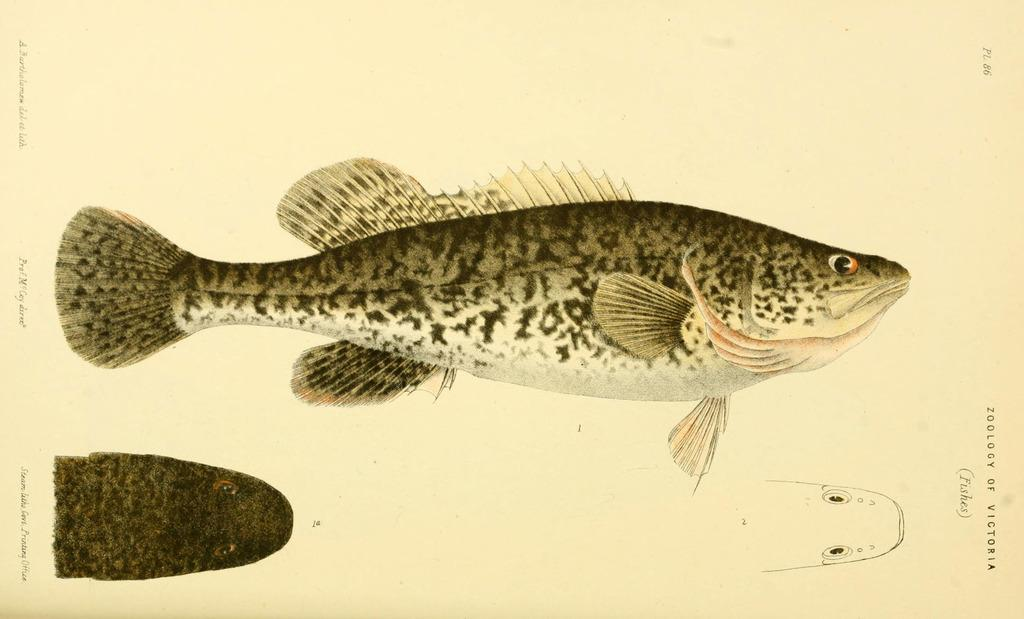What is the main subject of the image? There is a depiction of fish in the center of the image. What type of fuel is being used by the fish in the image? There is no mention of fuel or any type of propulsion in the image; it simply depicts fish. 